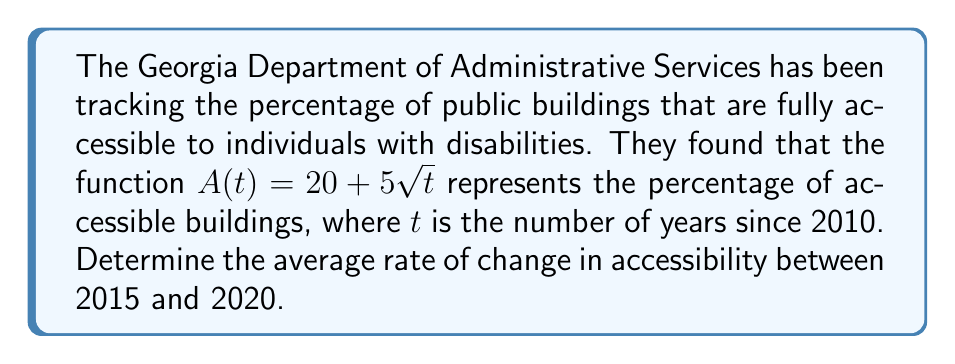Can you answer this question? To solve this problem, we need to follow these steps:

1. Identify the points in time:
   2015 is 5 years after 2010, so $t_1 = 5$
   2020 is 10 years after 2010, so $t_2 = 10$

2. Calculate $A(t)$ for both points:
   $A(5) = 20 + 5\sqrt{5}$
   $A(10) = 20 + 5\sqrt{10}$

3. Use the average rate of change formula:
   Average rate of change = $\frac{A(t_2) - A(t_1)}{t_2 - t_1}$

4. Substitute the values:
   $\frac{A(10) - A(5)}{10 - 5} = \frac{(20 + 5\sqrt{10}) - (20 + 5\sqrt{5})}{5}$

5. Simplify:
   $\frac{5\sqrt{10} - 5\sqrt{5}}{5} = \sqrt{10} - \sqrt{5}$

6. Calculate the final value:
   $\sqrt{10} - \sqrt{5} \approx 3.16228 - 2.23607 \approx 0.92621$

The average rate of change is approximately 0.92621 percent per year.
Answer: The average rate of change in accessibility between 2015 and 2020 is $\sqrt{10} - \sqrt{5} \approx 0.92621$ percent per year. 